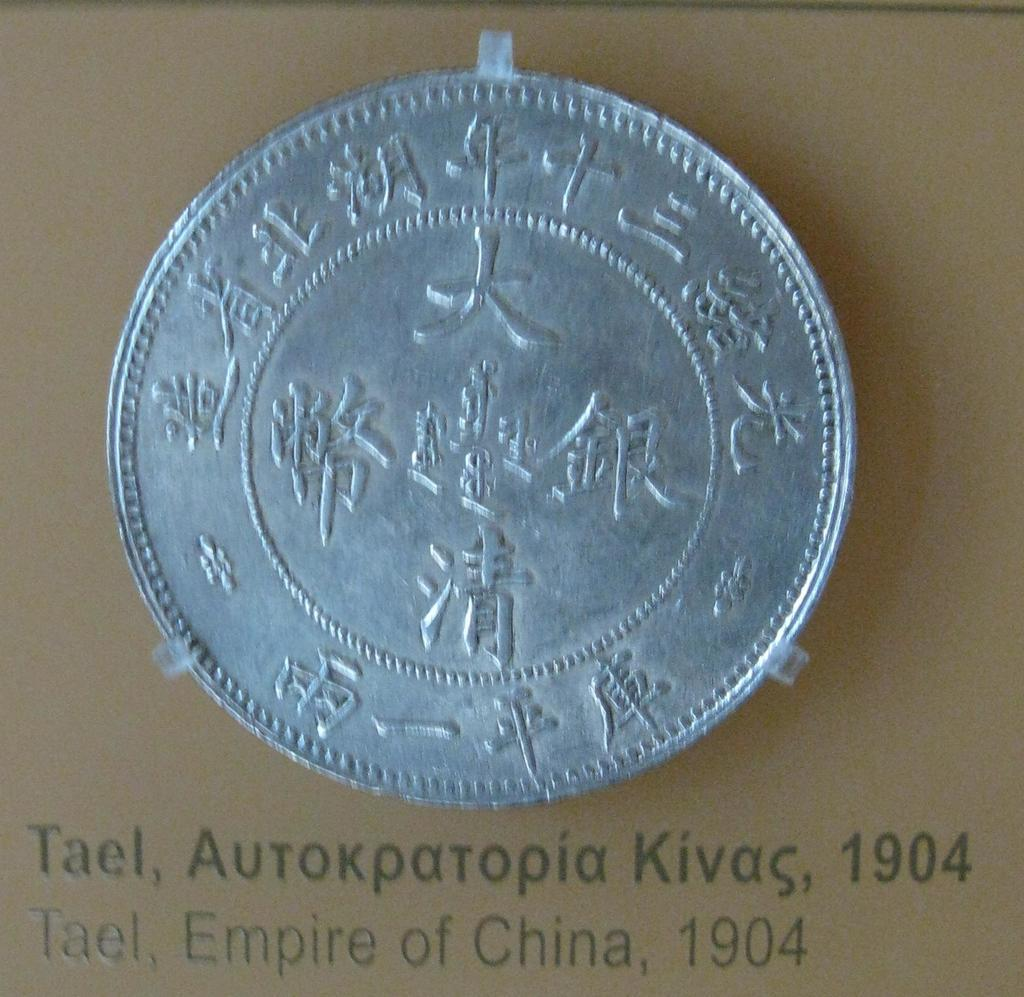<image>
Create a compact narrative representing the image presented. A silver colored coin from the Empire of China taped on a brown cardboard background. 